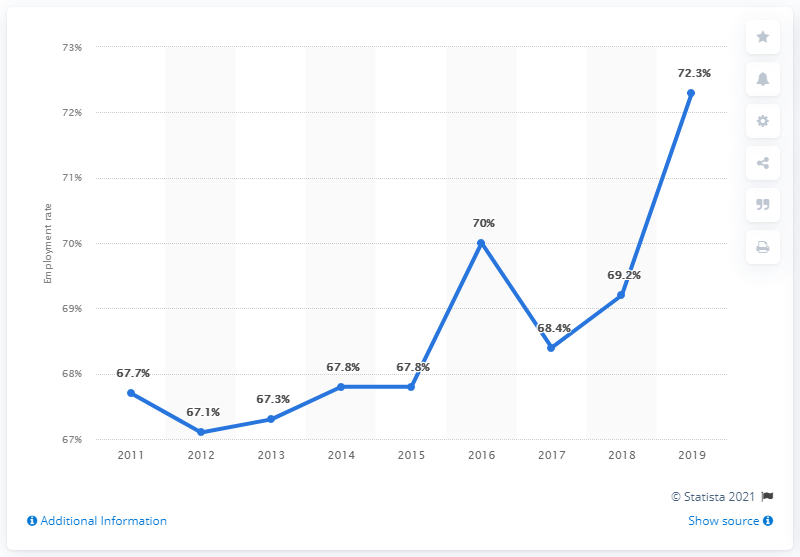List a handful of essential elements in this visual. In 2019, there was a significant increase in the employment rate, making it a notable year in terms of job growth. In 2016, the employment rate was 70%. 